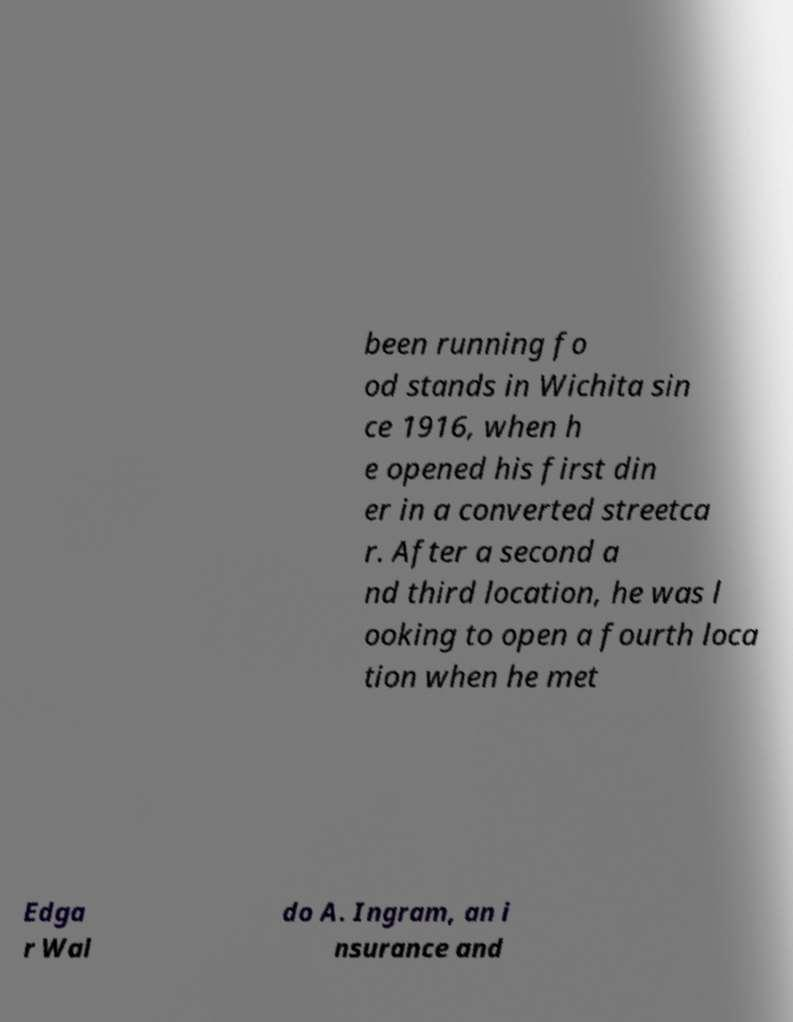There's text embedded in this image that I need extracted. Can you transcribe it verbatim? been running fo od stands in Wichita sin ce 1916, when h e opened his first din er in a converted streetca r. After a second a nd third location, he was l ooking to open a fourth loca tion when he met Edga r Wal do A. Ingram, an i nsurance and 